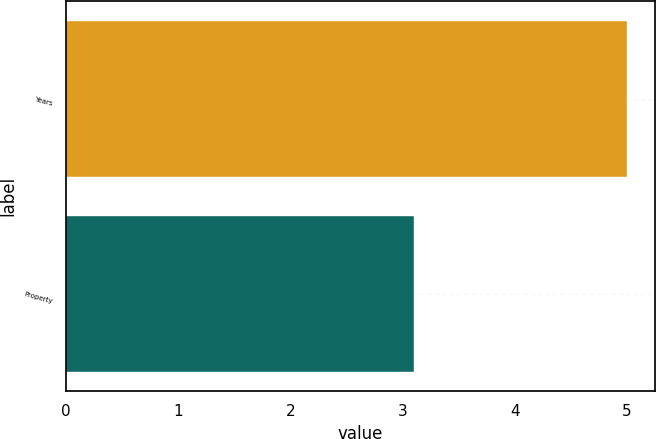Convert chart. <chart><loc_0><loc_0><loc_500><loc_500><bar_chart><fcel>Years<fcel>Property<nl><fcel>5<fcel>3.1<nl></chart> 